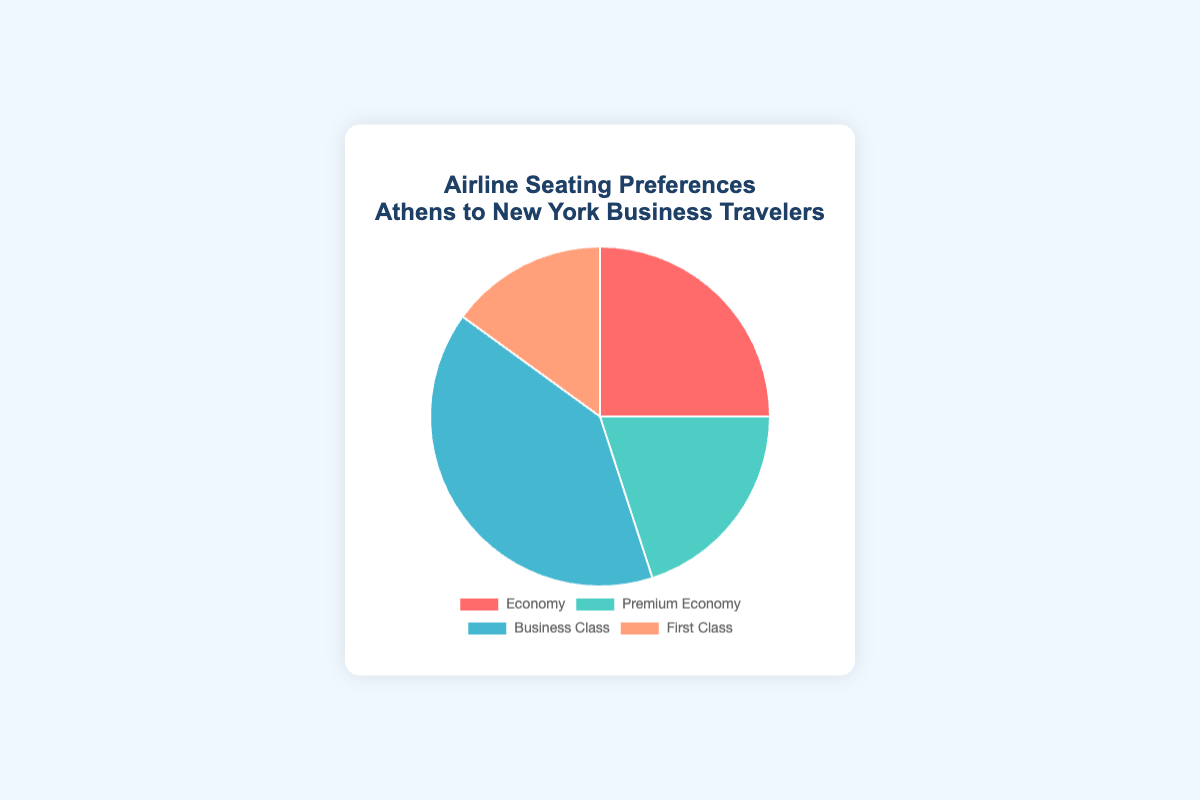Which seating type is the most preferred among business travelers from Athens to New York? The pie chart shows the proportion of preferences for different seating types. 'Business Class' has the largest section of the pie chart, indicating it is the most preferred.
Answer: Business Class What percentage of travelers prefer Economy or Premium Economy combined? The percentage of travelers who prefer Economy and Premium Economy combined can be found by summing their individual percentages: 25% (Economy) + 20% (Premium Economy) = 45%.
Answer: 45% How much more popular is Business Class compared to First Class? The popularity difference is determined by subtracting the percentage of First Class from Business Class: 40% (Business Class) - 15% (First Class) = 25%.
Answer: 25% Which seating type has the smallest preference percentage? The pie chart sections represent different seating preferences, and the smallest section corresponds to First Class at 15%.
Answer: First Class What is the average preference percentage for all seating types? To find the average preference percentage, sum all the percentages and divide by the number of seating types: (25% + 20% + 40% + 15%) / 4 = 100% / 4 = 25%.
Answer: 25% If you combined Business Class and Premium Economy, what percentage of travelers would prefer these combined classes? Adding the percentages for Business Class and Premium Economy gives: 40% (Business Class) + 20% (Premium Economy) = 60%.
Answer: 60% Compare the preference percentage of Economy to that of Premium Economy. Which is higher, and by how much? Economy has a preference percentage of 25%, while Premium Economy has 20%. Economy is higher by: 25% - 20% = 5%.
Answer: Economy is higher by 5% What fraction of the total pie chart does the Premium Economy section represent? Premium Economy represents 20% of the preferences. Converting this to a fraction of the total pie chart gives: 20/100 = 1/5.
Answer: 1/5 Are more travelers choosing Business Class or the combined options of Economy and First Class? Summing up Economy and First Class gives: 25% (Economy) + 15% (First Class) = 40%. Business Class also has 40%. Therefore, the numbers are equal.
Answer: Equal What is the difference in preference percentage between the least popular and most popular seating types? The least popular is First Class with 15%, and the most popular is Business Class with 40%. The difference is: 40% - 15% = 25%.
Answer: 25% 